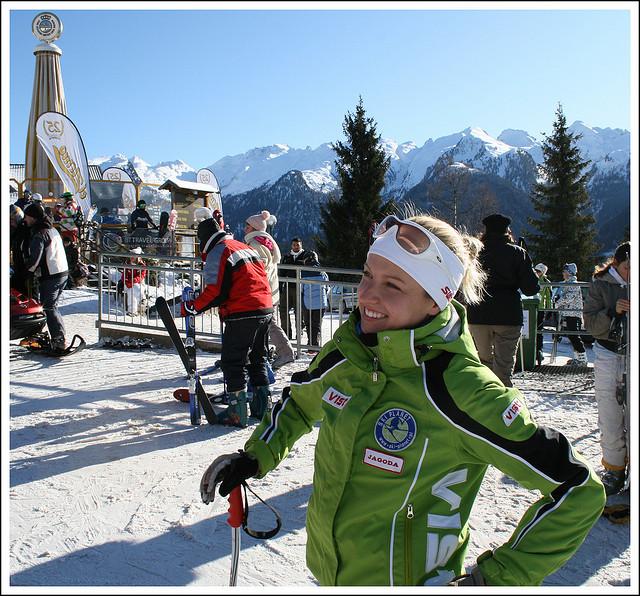What color is this woman's jacket?
Be succinct. Green. Is that snow on the mountain tops?
Keep it brief. Yes. Are there any trees pictured?
Be succinct. Yes. 